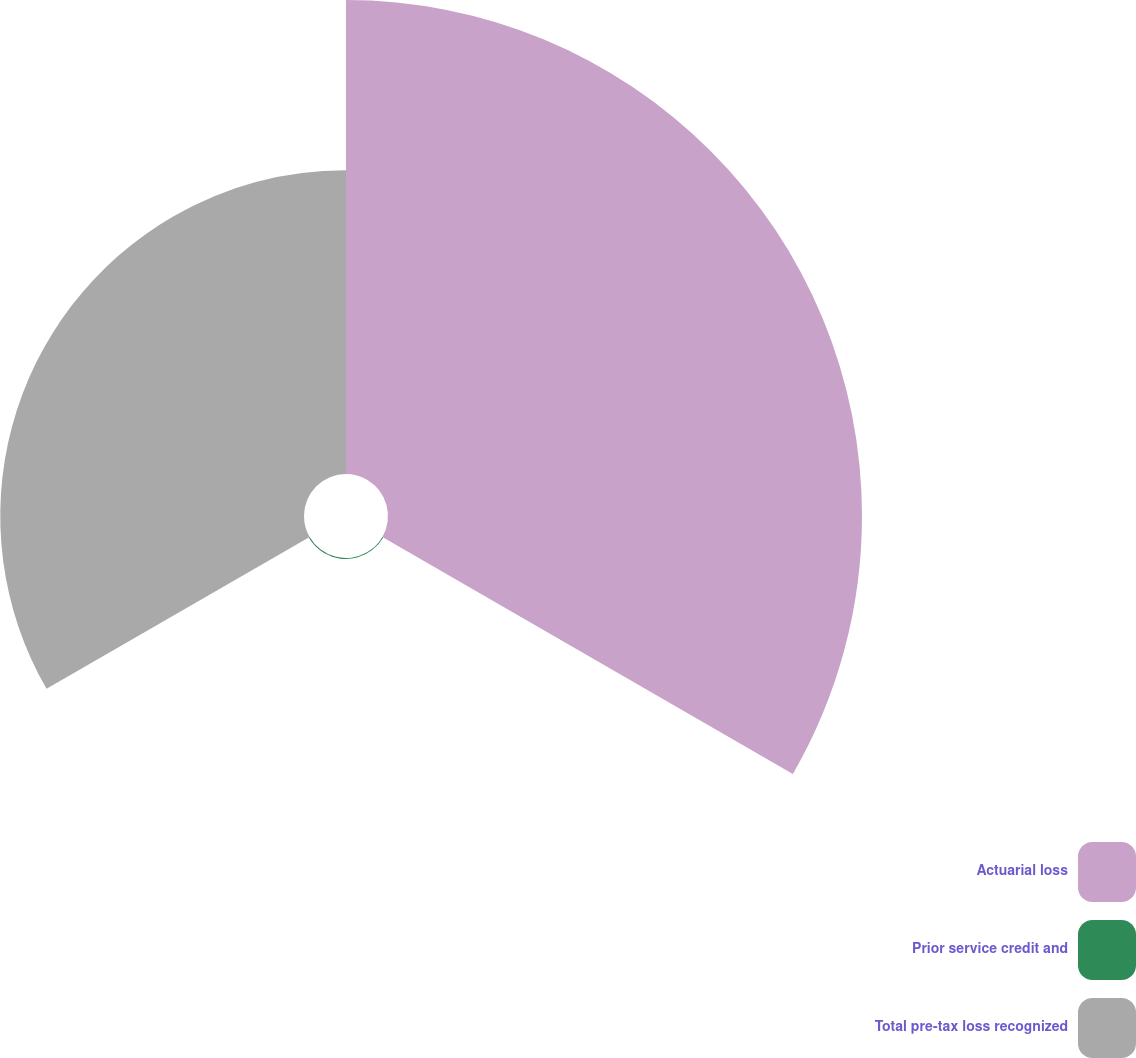Convert chart. <chart><loc_0><loc_0><loc_500><loc_500><pie_chart><fcel>Actuarial loss<fcel>Prior service credit and<fcel>Total pre-tax loss recognized<nl><fcel>60.86%<fcel>0.13%<fcel>39.0%<nl></chart> 